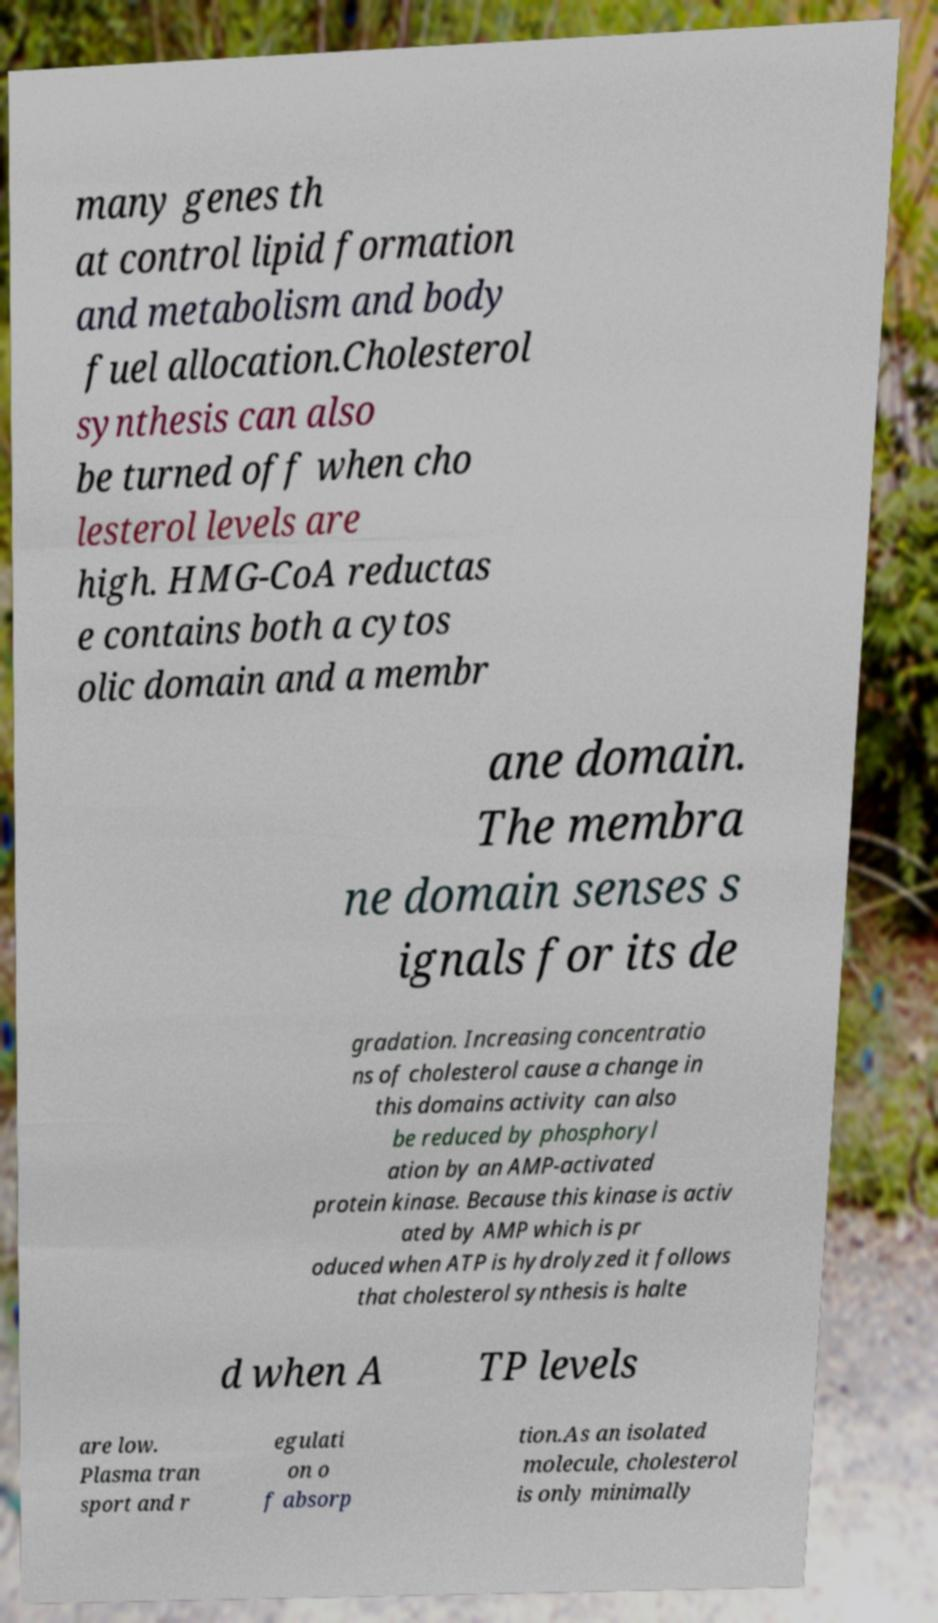Please read and relay the text visible in this image. What does it say? many genes th at control lipid formation and metabolism and body fuel allocation.Cholesterol synthesis can also be turned off when cho lesterol levels are high. HMG-CoA reductas e contains both a cytos olic domain and a membr ane domain. The membra ne domain senses s ignals for its de gradation. Increasing concentratio ns of cholesterol cause a change in this domains activity can also be reduced by phosphoryl ation by an AMP-activated protein kinase. Because this kinase is activ ated by AMP which is pr oduced when ATP is hydrolyzed it follows that cholesterol synthesis is halte d when A TP levels are low. Plasma tran sport and r egulati on o f absorp tion.As an isolated molecule, cholesterol is only minimally 